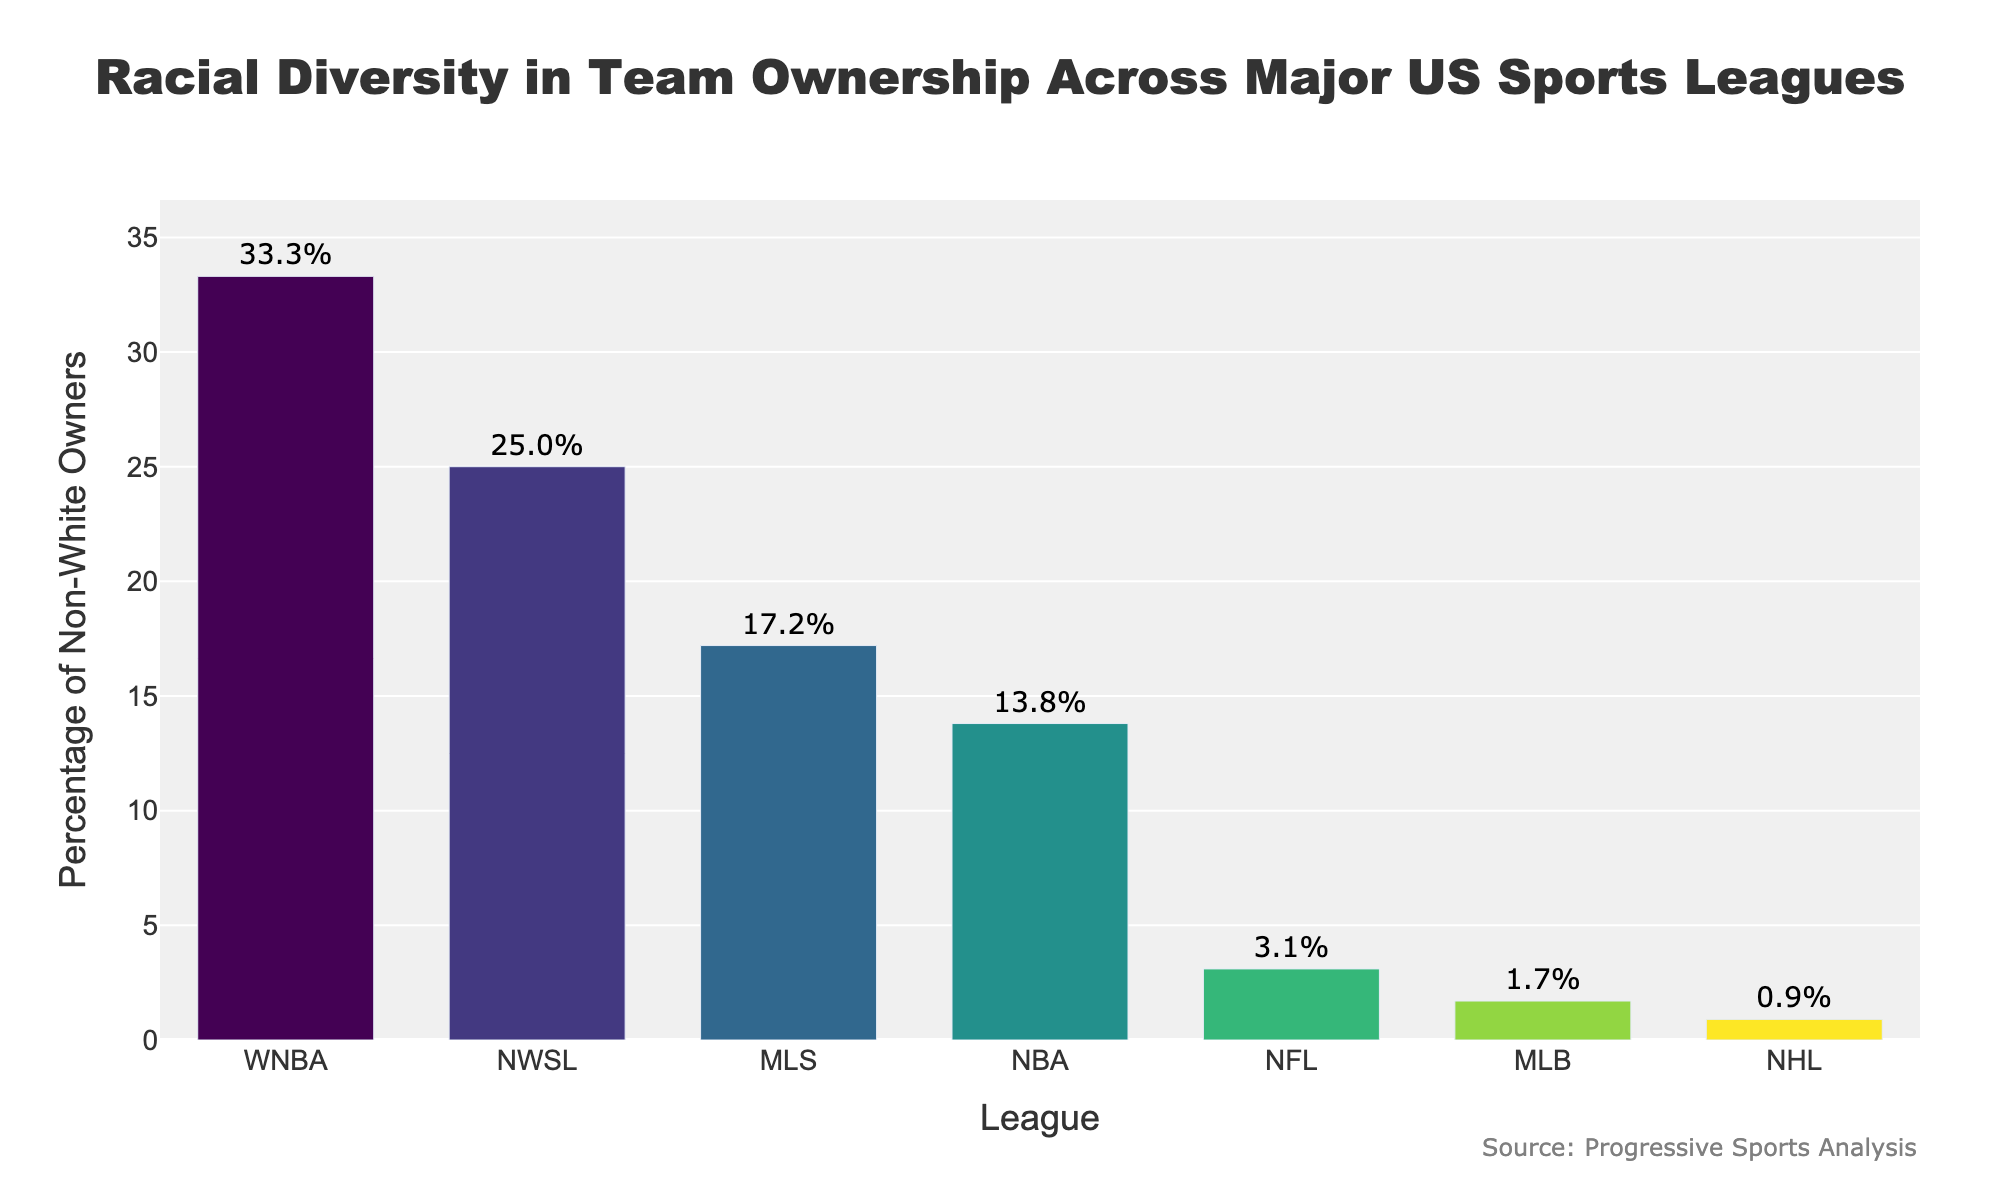Which league has the highest percentage of non-white owners? By inspecting the heights of the bars, the bar for the WNBA is the tallest, indicating the highest percentage of non-white owners.
Answer: WNBA What is the combined percentage of non-white owners in the NFL and NBA? From the chart, the NFL has 3.1% and the NBA has 13.8%. Adding them together: 3.1% + 13.8% = 16.9%.
Answer: 16.9% Which league has a lower percentage of non-white owners, MLB or NHL? By comparing the heights of the bars for MLB and NHL, the bar for the NHL is shorter. MLB has 1.7% and the NHL has 0.9%.
Answer: NHL Are there any leagues with a percentage of non-white owners that is greater than 20%? By observing the bars, both the WNBA (33.3%) and NWSL (25.0%) have percentages above 20%.
Answer: Yes What is the average percentage of non-white owners across all leagues shown in the chart? Sum the percentages of non-white owners from all leagues: 3.1% (NFL) + 13.8% (NBA) + 1.7% (MLB) + 0.9% (NHL) + 17.2% (MLS) + 33.3% (WNBA) + 25.0% (NWSL) = 95%. There are 7 leagues, so the average is 95% / 7 = 13.57%.
Answer: 13.57% How much higher is the percentage of non-white owners in MLS compared to MLB? The MLS has 17.2% and MLB has 1.7%. The difference is 17.2% - 1.7% = 15.5%.
Answer: 15.5% Which two leagues have the closest percentages of non-white owners? By comparing the values, the nearest are NFL (3.1%) and MLB (1.7%) with a difference of 1.4%.
Answer: NFL and MLB What percentage of non-white owners does the league with the third-highest percentage have? The third-highest percentage belongs to the NWSL, as the WNBA (33.3%) is first, MLS (17.2%) is second, and NWSL (25.0%) is third.
Answer: NWSL, 25.0% Is the percentage of non-white owners in the NBA more than double that of the NHL? The NBA has 13.8%, and the NHL has 0.9%. Doubling the NHL's percentage gives 0.9% * 2 = 1.8%. Since 13.8% is greater than 1.8%, the NBA's percentage is more than double that of the NHL.
Answer: Yes What is the difference between the highest and lowest percentages of non-white owners? The highest percentage is 33.3% (WNBA) and the lowest is 0.9% (NHL). The difference is 33.3% - 0.9% = 32.4%.
Answer: 32.4% 